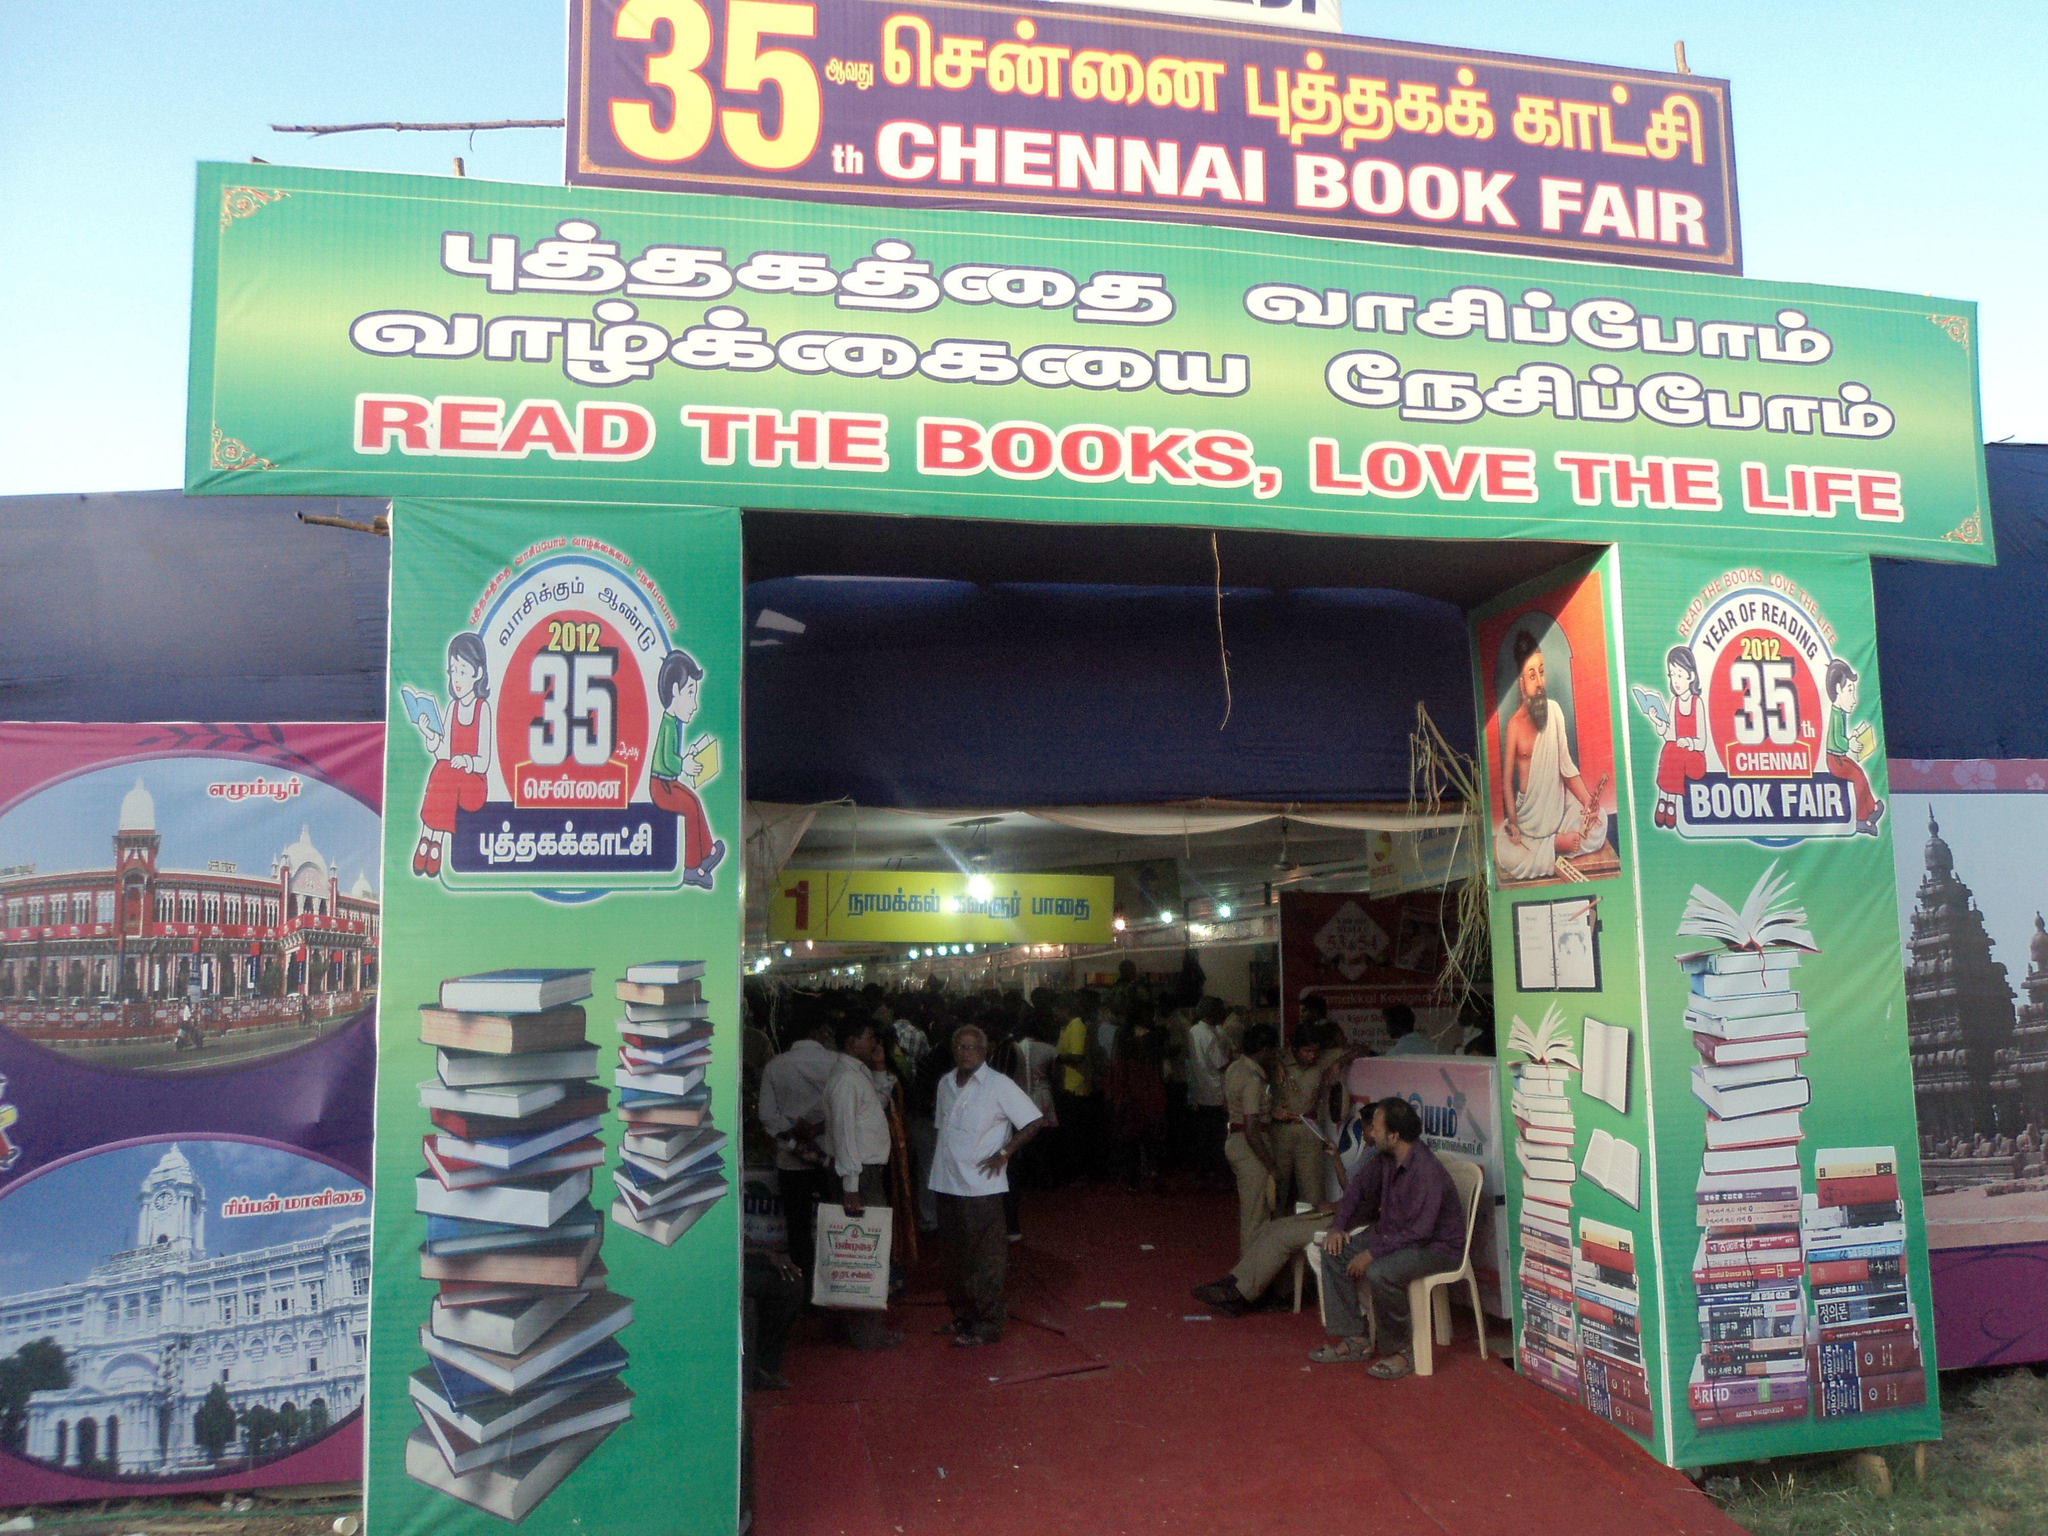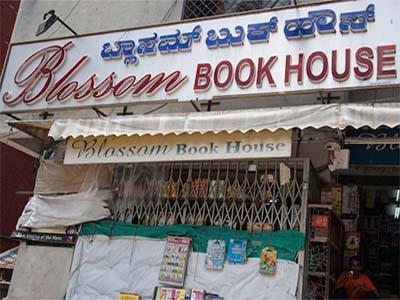The first image is the image on the left, the second image is the image on the right. Considering the images on both sides, is "Left images shows a shop with a lattice-like structure in front, behind a banner sign." valid? Answer yes or no. No. The first image is the image on the left, the second image is the image on the right. Given the left and right images, does the statement "People stand in the entrance of the store in the image on the left." hold true? Answer yes or no. Yes. 